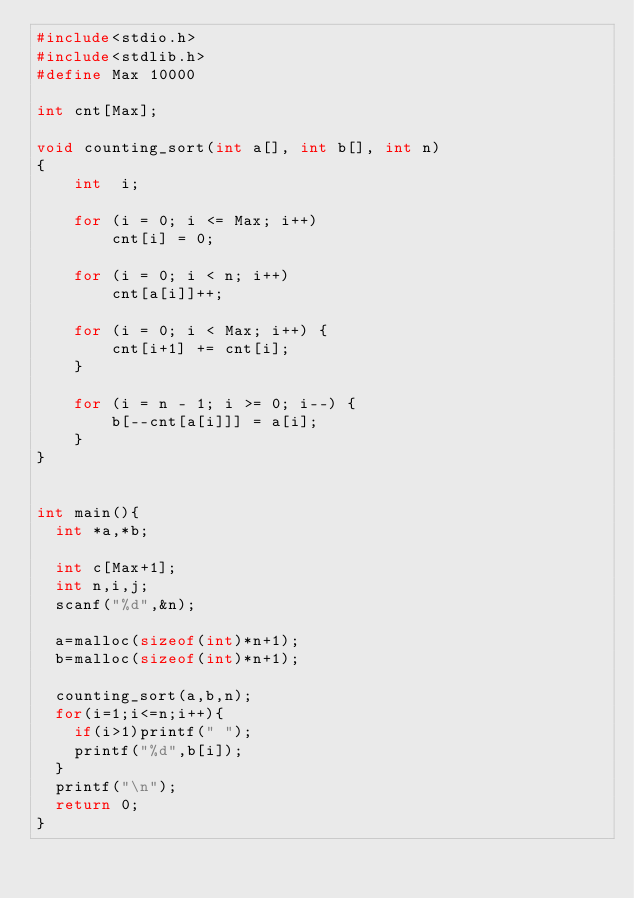<code> <loc_0><loc_0><loc_500><loc_500><_C_>#include<stdio.h>
#include<stdlib.h>
#define Max 10000

int cnt[Max];

void counting_sort(int a[], int b[], int n)
{
    int  i;

    for (i = 0; i <= Max; i++)
        cnt[i] = 0;

    for (i = 0; i < n; i++)
        cnt[a[i]]++;

    for (i = 0; i < Max; i++) {
        cnt[i+1] += cnt[i];
    }

    for (i = n - 1; i >= 0; i--) {
        b[--cnt[a[i]]] = a[i];
    }
}


int main(){
  int *a,*b;

  int c[Max+1];
  int n,i,j;
  scanf("%d",&n);

  a=malloc(sizeof(int)*n+1);
  b=malloc(sizeof(int)*n+1);

  counting_sort(a,b,n);
  for(i=1;i<=n;i++){
    if(i>1)printf(" ");
    printf("%d",b[i]);
  }
  printf("\n");
  return 0;
}

</code> 